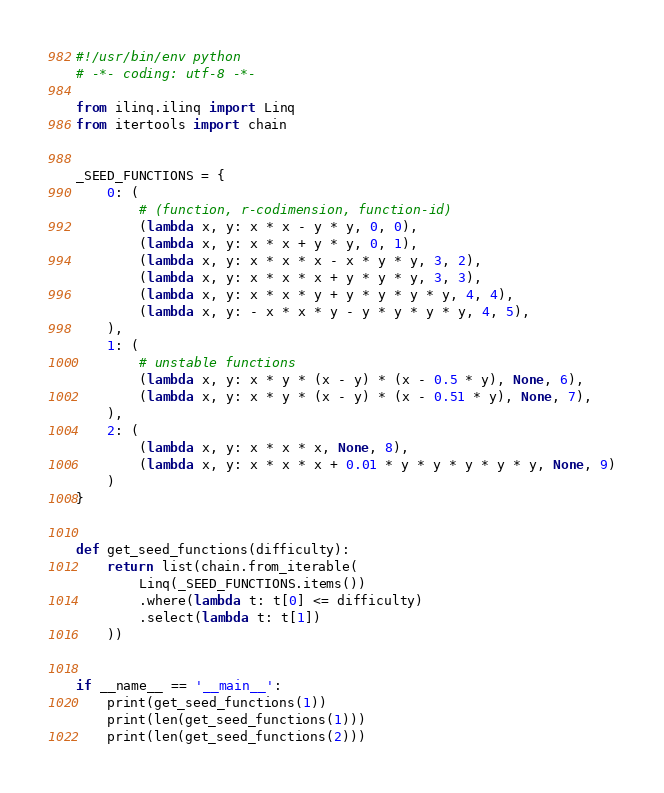Convert code to text. <code><loc_0><loc_0><loc_500><loc_500><_Python_>#!/usr/bin/env python
# -*- coding: utf-8 -*-

from ilinq.ilinq import Linq
from itertools import chain


_SEED_FUNCTIONS = {
    0: (
        # (function, r-codimension, function-id)
        (lambda x, y: x * x - y * y, 0, 0),
        (lambda x, y: x * x + y * y, 0, 1),
        (lambda x, y: x * x * x - x * y * y, 3, 2),
        (lambda x, y: x * x * x + y * y * y, 3, 3),
        (lambda x, y: x * x * y + y * y * y * y, 4, 4),
        (lambda x, y: - x * x * y - y * y * y * y, 4, 5),
    ),
    1: (
        # unstable functions
        (lambda x, y: x * y * (x - y) * (x - 0.5 * y), None, 6),
        (lambda x, y: x * y * (x - y) * (x - 0.51 * y), None, 7),
    ),
    2: (
        (lambda x, y: x * x * x, None, 8),
        (lambda x, y: x * x * x + 0.01 * y * y * y * y * y, None, 9)
    )
}


def get_seed_functions(difficulty):
    return list(chain.from_iterable(
        Linq(_SEED_FUNCTIONS.items())
        .where(lambda t: t[0] <= difficulty)
        .select(lambda t: t[1])
    ))


if __name__ == '__main__':
    print(get_seed_functions(1))
    print(len(get_seed_functions(1)))
    print(len(get_seed_functions(2)))
</code> 